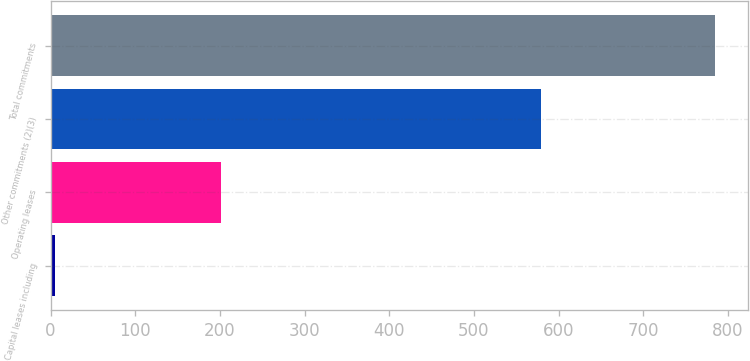<chart> <loc_0><loc_0><loc_500><loc_500><bar_chart><fcel>Capital leases including<fcel>Operating leases<fcel>Other commitments (2)(3)<fcel>Total commitments<nl><fcel>5<fcel>201<fcel>579<fcel>785<nl></chart> 